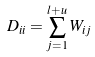<formula> <loc_0><loc_0><loc_500><loc_500>D _ { i i } = \sum _ { j = 1 } ^ { l + u } W _ { i j }</formula> 